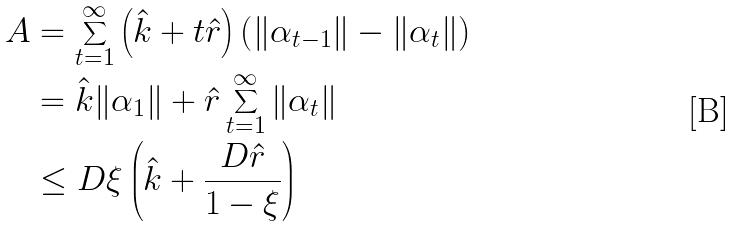Convert formula to latex. <formula><loc_0><loc_0><loc_500><loc_500>A & = \sum _ { t = 1 } ^ { \infty } \left ( \hat { k } + t \hat { r } \right ) \left ( \| \alpha _ { t - 1 } \| - \| \alpha _ { t } \| \right ) \\ & = \hat { k } \| \alpha _ { 1 } \| + \hat { r } \sum _ { t = 1 } ^ { \infty } \| \alpha _ { t } \| \\ & \leq D \xi \left ( \hat { k } + \frac { D \hat { r } } { 1 - \xi } \right )</formula> 